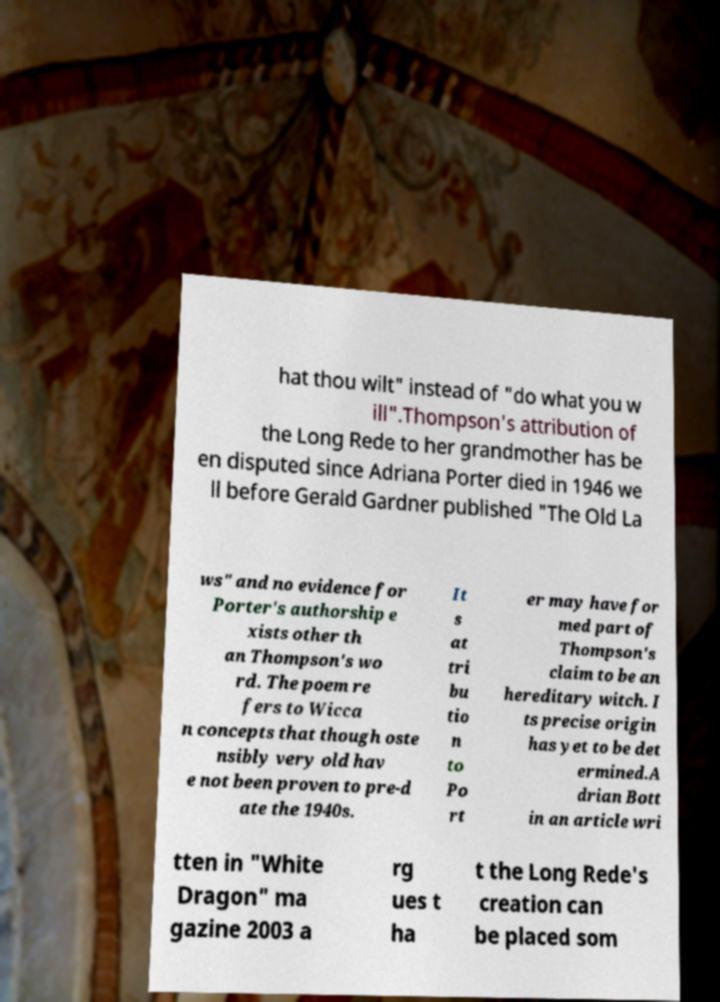What messages or text are displayed in this image? I need them in a readable, typed format. hat thou wilt" instead of "do what you w ill".Thompson's attribution of the Long Rede to her grandmother has be en disputed since Adriana Porter died in 1946 we ll before Gerald Gardner published "The Old La ws" and no evidence for Porter's authorship e xists other th an Thompson's wo rd. The poem re fers to Wicca n concepts that though oste nsibly very old hav e not been proven to pre-d ate the 1940s. It s at tri bu tio n to Po rt er may have for med part of Thompson's claim to be an hereditary witch. I ts precise origin has yet to be det ermined.A drian Bott in an article wri tten in "White Dragon" ma gazine 2003 a rg ues t ha t the Long Rede's creation can be placed som 